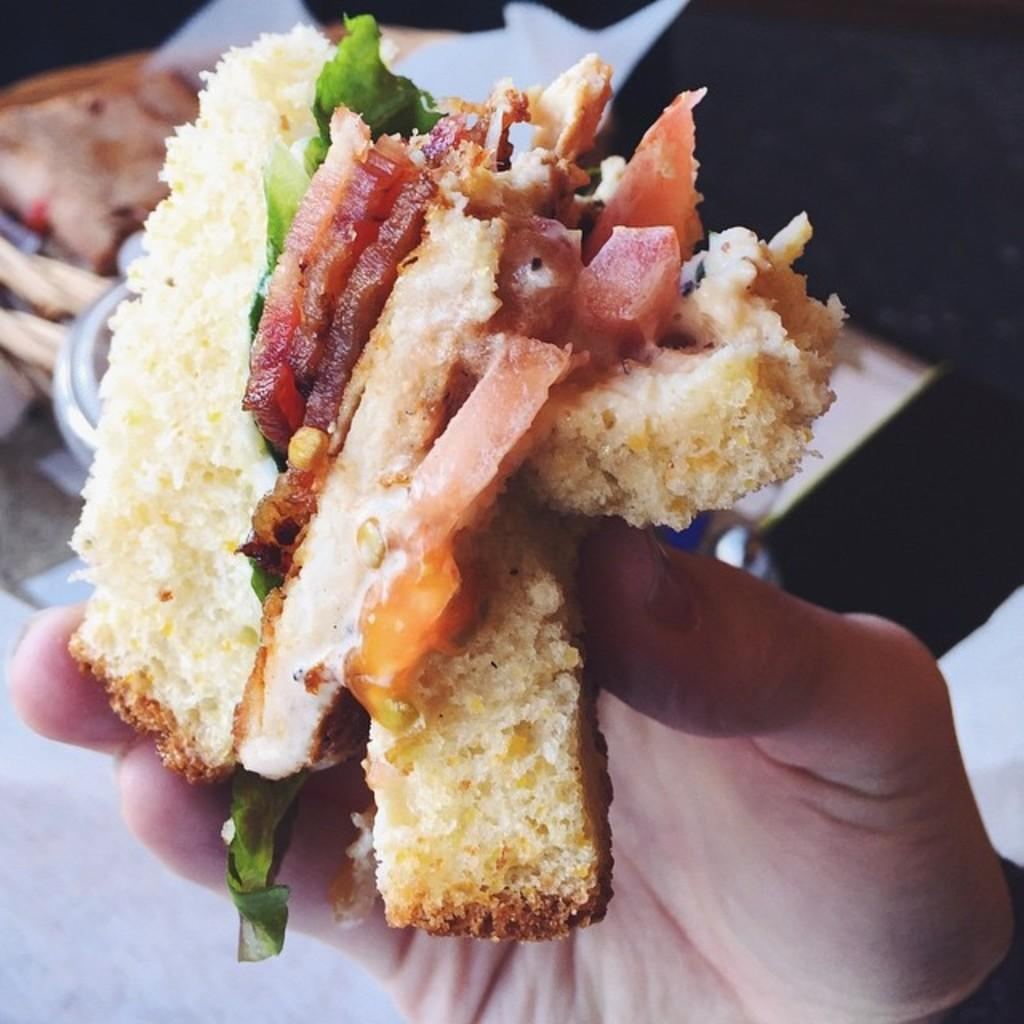What is the person in the center of the image holding? There is food in a person's hand in the center of the image. Can you describe the food visible in the background? Unfortunately, the facts provided do not give any details about the food visible in the background. What is placed on the table in the background? There is a bowl placed on the table in the background. What type of railway can be seen in the image? There is no railway present in the image. What color are the trousers worn by the person in the image? The facts provided do not give any information about the person's clothing, including their trousers. 